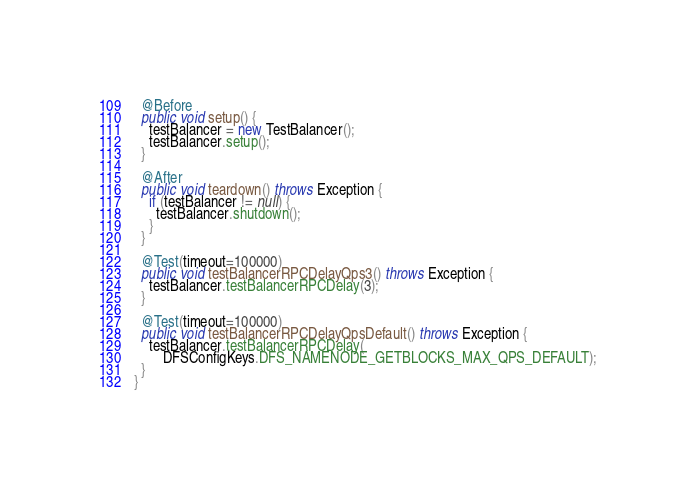Convert code to text. <code><loc_0><loc_0><loc_500><loc_500><_Java_>
  @Before
  public void setup() {
    testBalancer = new TestBalancer();
    testBalancer.setup();
  }

  @After
  public void teardown() throws Exception {
    if (testBalancer != null) {
      testBalancer.shutdown();
    }
  }

  @Test(timeout=100000)
  public void testBalancerRPCDelayQps3() throws Exception {
    testBalancer.testBalancerRPCDelay(3);
  }

  @Test(timeout=100000)
  public void testBalancerRPCDelayQpsDefault() throws Exception {
    testBalancer.testBalancerRPCDelay(
        DFSConfigKeys.DFS_NAMENODE_GETBLOCKS_MAX_QPS_DEFAULT);
  }
}
</code> 